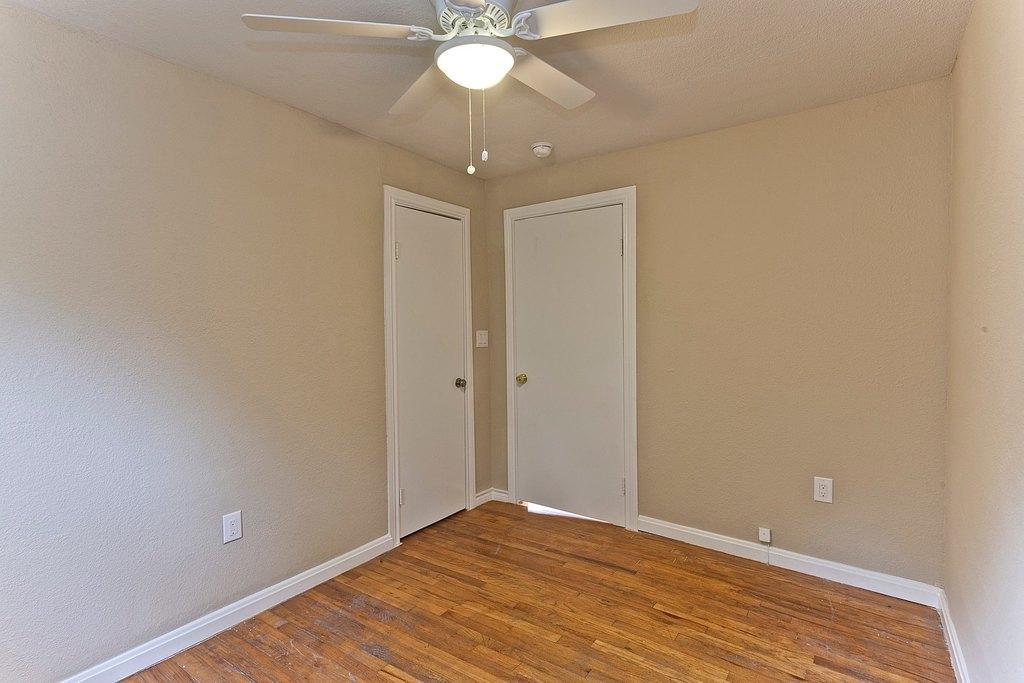Could you give a brief overview of what you see in this image? This is the picture of a room, we can see a brown color floor, there are two white color doors, we can see some walls, at the top there is a ceiling fan. 